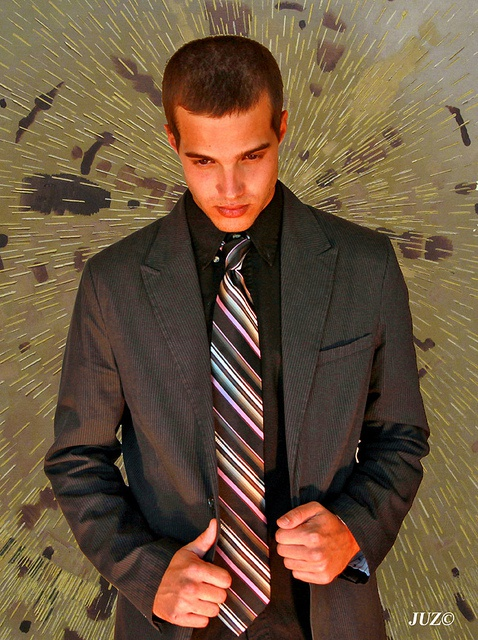Describe the objects in this image and their specific colors. I can see people in gray, black, maroon, and salmon tones and tie in gray, black, maroon, white, and brown tones in this image. 